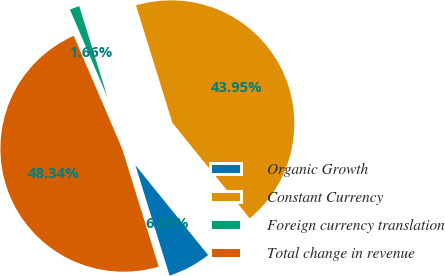Convert chart to OTSL. <chart><loc_0><loc_0><loc_500><loc_500><pie_chart><fcel>Organic Growth<fcel>Constant Currency<fcel>Foreign currency translation<fcel>Total change in revenue<nl><fcel>6.05%<fcel>43.95%<fcel>1.66%<fcel>48.34%<nl></chart> 